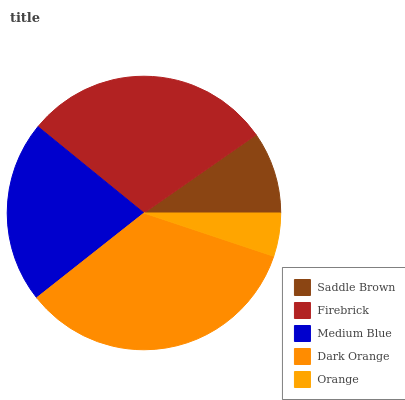Is Orange the minimum?
Answer yes or no. Yes. Is Dark Orange the maximum?
Answer yes or no. Yes. Is Firebrick the minimum?
Answer yes or no. No. Is Firebrick the maximum?
Answer yes or no. No. Is Firebrick greater than Saddle Brown?
Answer yes or no. Yes. Is Saddle Brown less than Firebrick?
Answer yes or no. Yes. Is Saddle Brown greater than Firebrick?
Answer yes or no. No. Is Firebrick less than Saddle Brown?
Answer yes or no. No. Is Medium Blue the high median?
Answer yes or no. Yes. Is Medium Blue the low median?
Answer yes or no. Yes. Is Saddle Brown the high median?
Answer yes or no. No. Is Orange the low median?
Answer yes or no. No. 